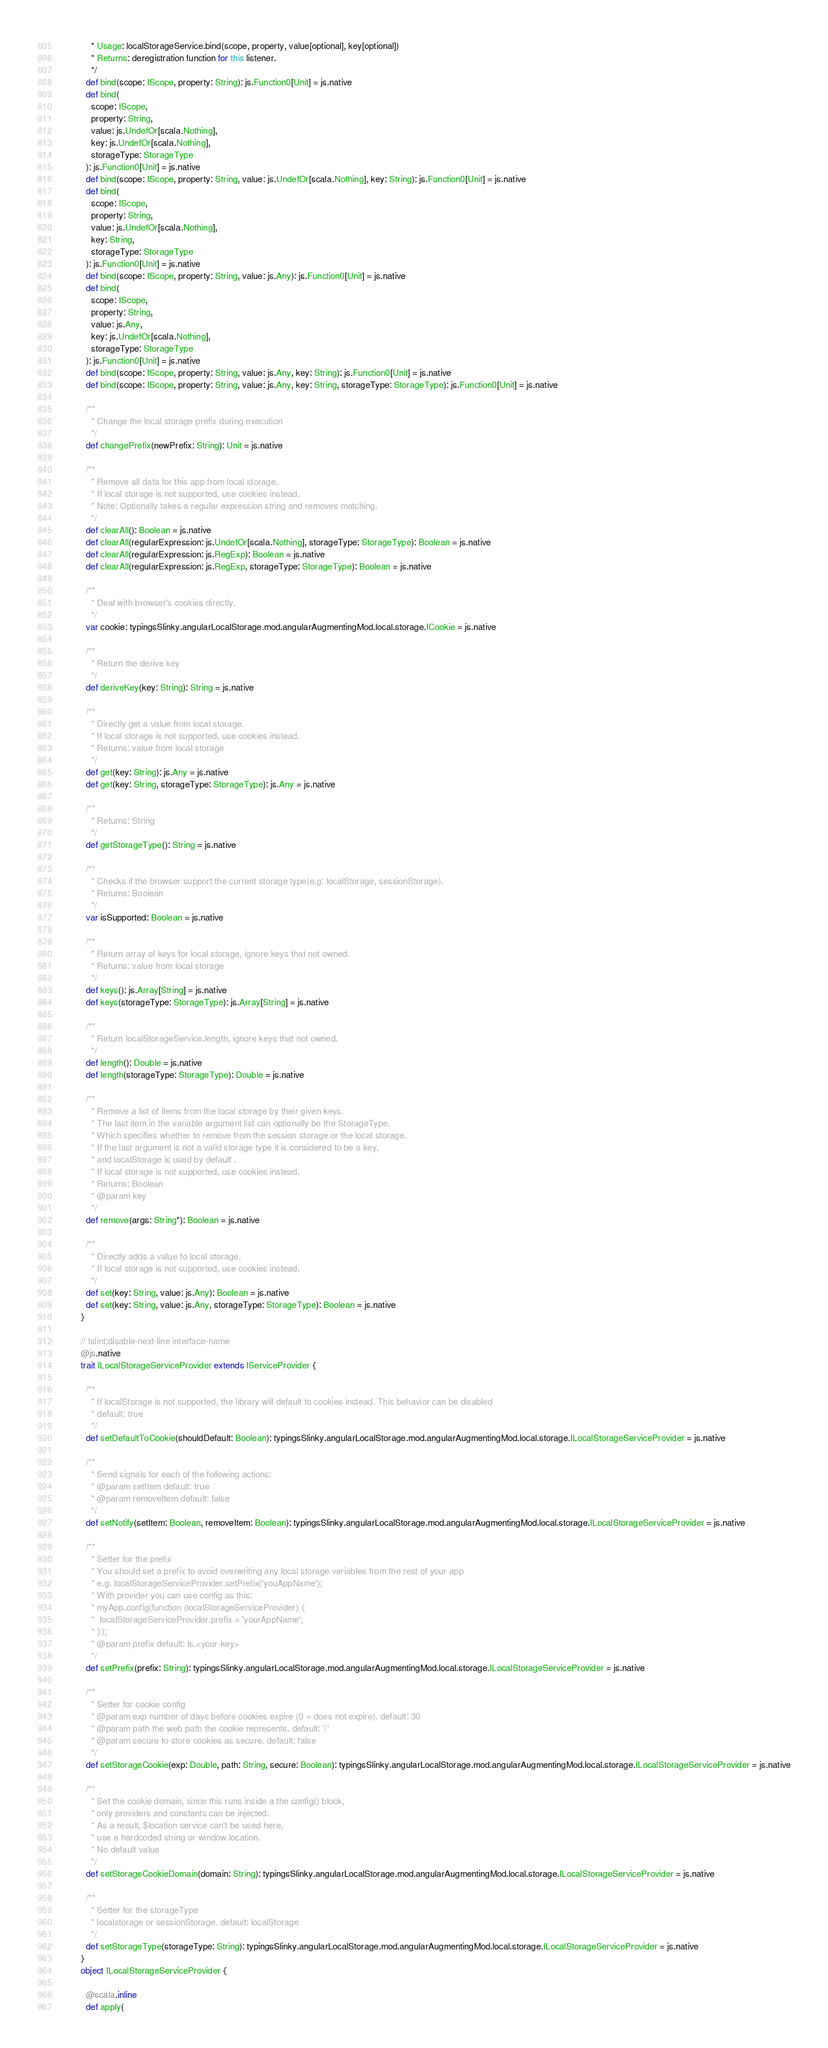<code> <loc_0><loc_0><loc_500><loc_500><_Scala_>            * Usage: localStorageService.bind(scope, property, value[optional], key[optional])
            * Returns: deregistration function for this listener.
            */
          def bind(scope: IScope, property: String): js.Function0[Unit] = js.native
          def bind(
            scope: IScope,
            property: String,
            value: js.UndefOr[scala.Nothing],
            key: js.UndefOr[scala.Nothing],
            storageType: StorageType
          ): js.Function0[Unit] = js.native
          def bind(scope: IScope, property: String, value: js.UndefOr[scala.Nothing], key: String): js.Function0[Unit] = js.native
          def bind(
            scope: IScope,
            property: String,
            value: js.UndefOr[scala.Nothing],
            key: String,
            storageType: StorageType
          ): js.Function0[Unit] = js.native
          def bind(scope: IScope, property: String, value: js.Any): js.Function0[Unit] = js.native
          def bind(
            scope: IScope,
            property: String,
            value: js.Any,
            key: js.UndefOr[scala.Nothing],
            storageType: StorageType
          ): js.Function0[Unit] = js.native
          def bind(scope: IScope, property: String, value: js.Any, key: String): js.Function0[Unit] = js.native
          def bind(scope: IScope, property: String, value: js.Any, key: String, storageType: StorageType): js.Function0[Unit] = js.native
          
          /**
            * Change the local storage prefix during execution
            */
          def changePrefix(newPrefix: String): Unit = js.native
          
          /**
            * Remove all data for this app from local storage.
            * If local storage is not supported, use cookies instead.
            * Note: Optionally takes a regular expression string and removes matching.
            */
          def clearAll(): Boolean = js.native
          def clearAll(regularExpression: js.UndefOr[scala.Nothing], storageType: StorageType): Boolean = js.native
          def clearAll(regularExpression: js.RegExp): Boolean = js.native
          def clearAll(regularExpression: js.RegExp, storageType: StorageType): Boolean = js.native
          
          /**
            * Deal with browser's cookies directly.
            */
          var cookie: typingsSlinky.angularLocalStorage.mod.angularAugmentingMod.local.storage.ICookie = js.native
          
          /**
            * Return the derive key
            */
          def deriveKey(key: String): String = js.native
          
          /**
            * Directly get a value from local storage.
            * If local storage is not supported, use cookies instead.
            * Returns: value from local storage
            */
          def get(key: String): js.Any = js.native
          def get(key: String, storageType: StorageType): js.Any = js.native
          
          /**
            * Returns: String
            */
          def getStorageType(): String = js.native
          
          /**
            * Checks if the browser support the current storage type(e.g: localStorage, sessionStorage).
            * Returns: Boolean
            */
          var isSupported: Boolean = js.native
          
          /**
            * Return array of keys for local storage, ignore keys that not owned.
            * Returns: value from local storage
            */
          def keys(): js.Array[String] = js.native
          def keys(storageType: StorageType): js.Array[String] = js.native
          
          /**
            * Return localStorageService.length, ignore keys that not owned.
            */
          def length(): Double = js.native
          def length(storageType: StorageType): Double = js.native
          
          /**
            * Remove a list of items from the local storage by their given keys.
            * The last item in the variable argument list can optionally be the StorageType.
            * Which specifies whether to remove from the session storage or the local storage.
            * If the last argument is not a valid storage type it is considered to be a key,
            * and localStorage is used by default .
            * If local storage is not supported, use cookies instead.
            * Returns: Boolean
            * @param key
            */
          def remove(args: String*): Boolean = js.native
          
          /**
            * Directly adds a value to local storage.
            * If local storage is not supported, use cookies instead.
            */
          def set(key: String, value: js.Any): Boolean = js.native
          def set(key: String, value: js.Any, storageType: StorageType): Boolean = js.native
        }
        
        // tslint:disable-next-line interface-name
        @js.native
        trait ILocalStorageServiceProvider extends IServiceProvider {
          
          /**
            * If localStorage is not supported, the library will default to cookies instead. This behavior can be disabled
            * default: true
            */
          def setDefaultToCookie(shouldDefault: Boolean): typingsSlinky.angularLocalStorage.mod.angularAugmentingMod.local.storage.ILocalStorageServiceProvider = js.native
          
          /**
            * Send signals for each of the following actions:
            * @param setItem default: true
            * @param removeItem default: false
            */
          def setNotify(setItem: Boolean, removeItem: Boolean): typingsSlinky.angularLocalStorage.mod.angularAugmentingMod.local.storage.ILocalStorageServiceProvider = js.native
          
          /**
            * Setter for the prefix
            * You should set a prefix to avoid overwriting any local storage variables from the rest of your app
            * e.g. localStorageServiceProvider.setPrefix('youAppName');
            * With provider you can use config as this:
            * myApp.config(function (localStorageServiceProvider) {
            *  localStorageServiceProvider.prefix = 'yourAppName';
            * });
            * @param prefix default: ls.<your-key>
            */
          def setPrefix(prefix: String): typingsSlinky.angularLocalStorage.mod.angularAugmentingMod.local.storage.ILocalStorageServiceProvider = js.native
          
          /**
            * Setter for cookie config
            * @param exp number of days before cookies expire (0 = does not expire). default: 30
            * @param path the web path the cookie represents. default: '/'
            * @param secure to store cookies as secure. default: false
            */
          def setStorageCookie(exp: Double, path: String, secure: Boolean): typingsSlinky.angularLocalStorage.mod.angularAugmentingMod.local.storage.ILocalStorageServiceProvider = js.native
          
          /**
            * Set the cookie domain, since this runs inside a the config() block,
            * only providers and constants can be injected.
            * As a result, $location service can't be used here,
            * use a hardcoded string or window.location.
            * No default value
            */
          def setStorageCookieDomain(domain: String): typingsSlinky.angularLocalStorage.mod.angularAugmentingMod.local.storage.ILocalStorageServiceProvider = js.native
          
          /**
            * Setter for the storageType
            * localstorage or sessionStorage. default: localStorage
            */
          def setStorageType(storageType: String): typingsSlinky.angularLocalStorage.mod.angularAugmentingMod.local.storage.ILocalStorageServiceProvider = js.native
        }
        object ILocalStorageServiceProvider {
          
          @scala.inline
          def apply(</code> 